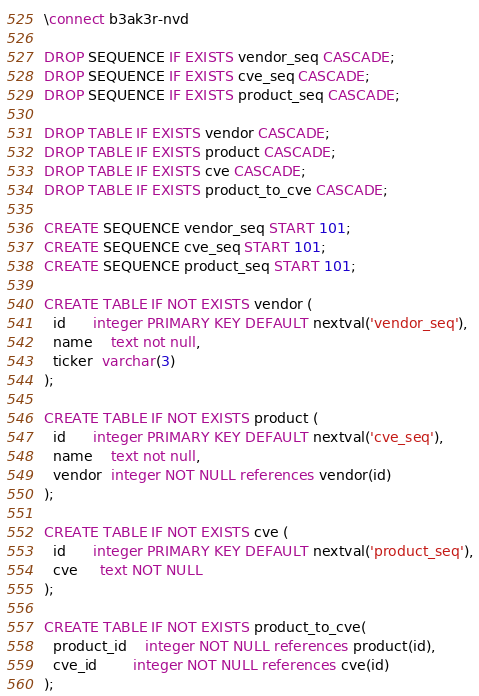Convert code to text. <code><loc_0><loc_0><loc_500><loc_500><_SQL_>\connect b3ak3r-nvd

DROP SEQUENCE IF EXISTS vendor_seq CASCADE;
DROP SEQUENCE IF EXISTS cve_seq CASCADE;
DROP SEQUENCE IF EXISTS product_seq CASCADE;

DROP TABLE IF EXISTS vendor CASCADE;
DROP TABLE IF EXISTS product CASCADE;
DROP TABLE IF EXISTS cve CASCADE;
DROP TABLE IF EXISTS product_to_cve CASCADE;

CREATE SEQUENCE vendor_seq START 101;
CREATE SEQUENCE cve_seq START 101;
CREATE SEQUENCE product_seq START 101;

CREATE TABLE IF NOT EXISTS vendor (
  id      integer PRIMARY KEY DEFAULT nextval('vendor_seq'),
  name    text not null,
  ticker  varchar(3)
);

CREATE TABLE IF NOT EXISTS product (
  id      integer PRIMARY KEY DEFAULT nextval('cve_seq'),
  name    text not null,
  vendor  integer NOT NULL references vendor(id)
);

CREATE TABLE IF NOT EXISTS cve (
  id      integer PRIMARY KEY DEFAULT nextval('product_seq'),
  cve     text NOT NULL
);

CREATE TABLE IF NOT EXISTS product_to_cve(
  product_id    integer NOT NULL references product(id),
  cve_id        integer NOT NULL references cve(id)
);
</code> 